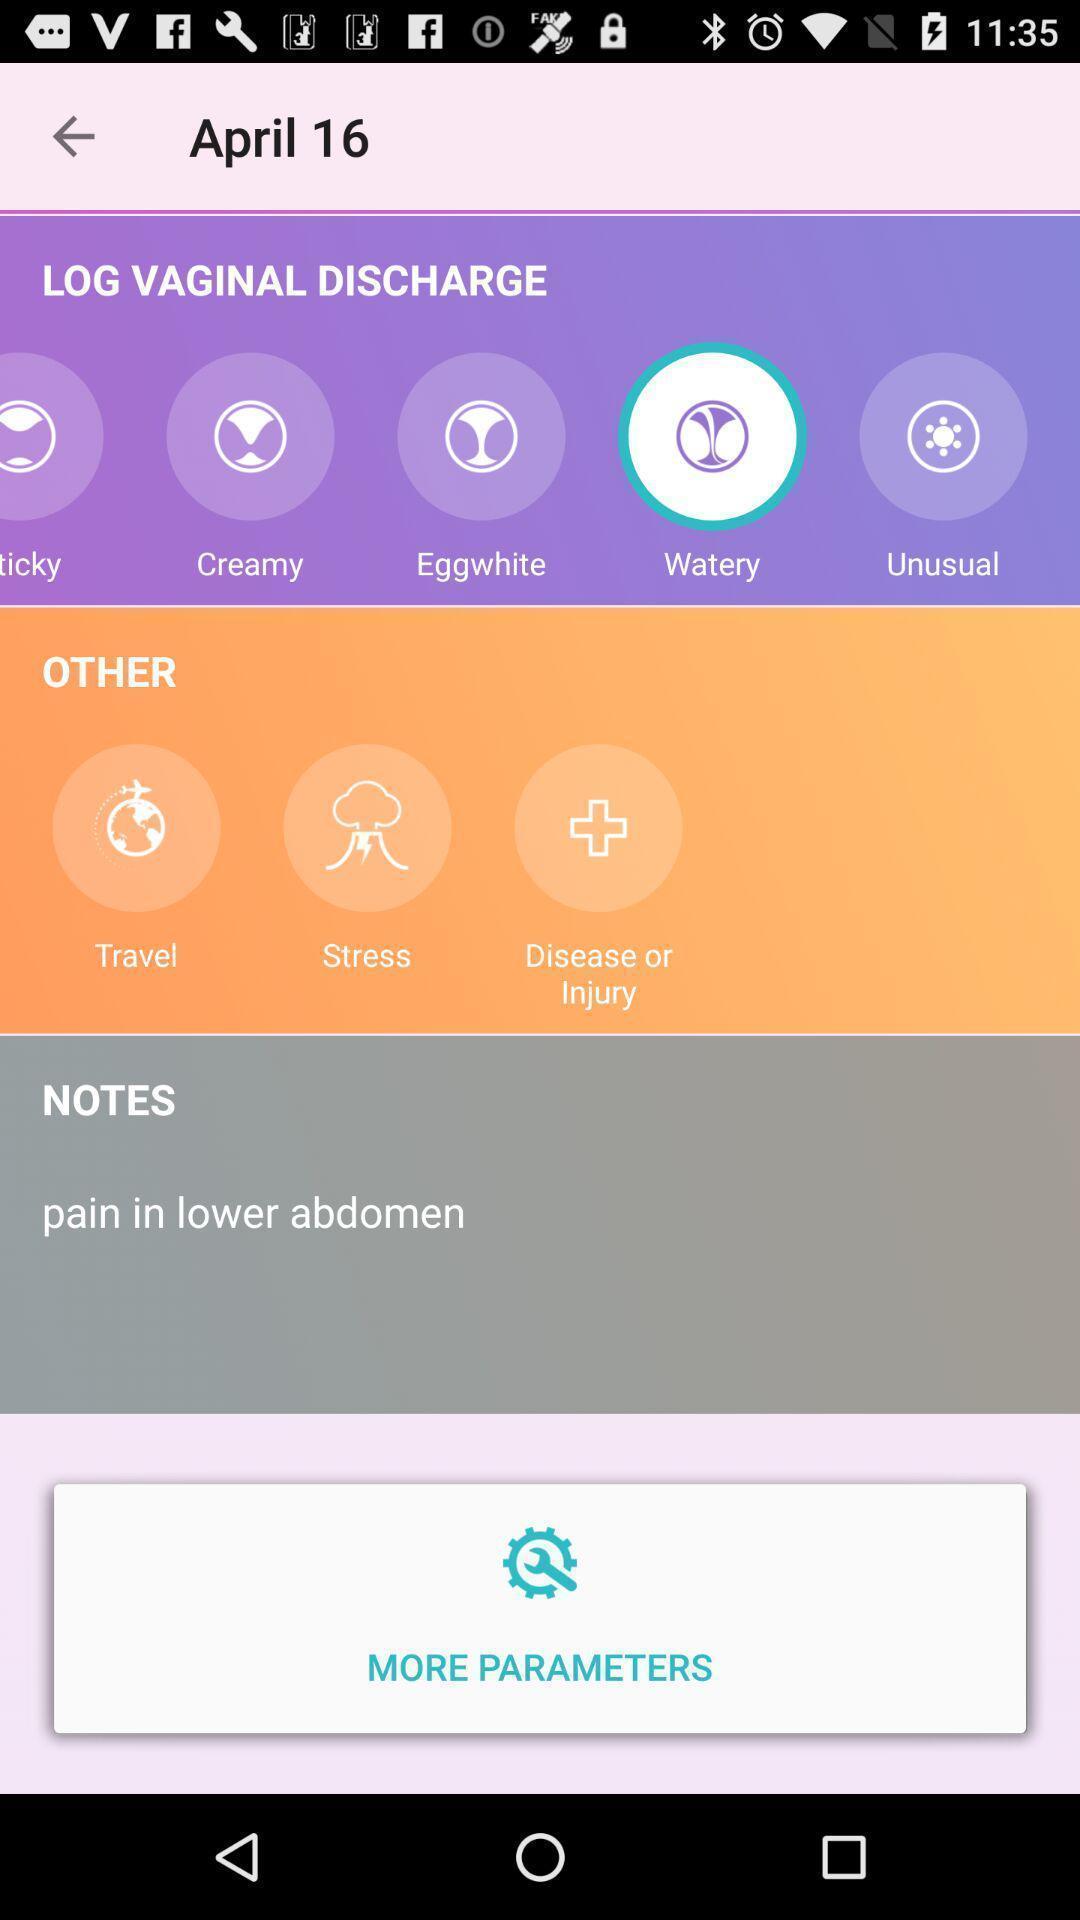Give me a narrative description of this picture. Screen displaying the options for food cooking app. 